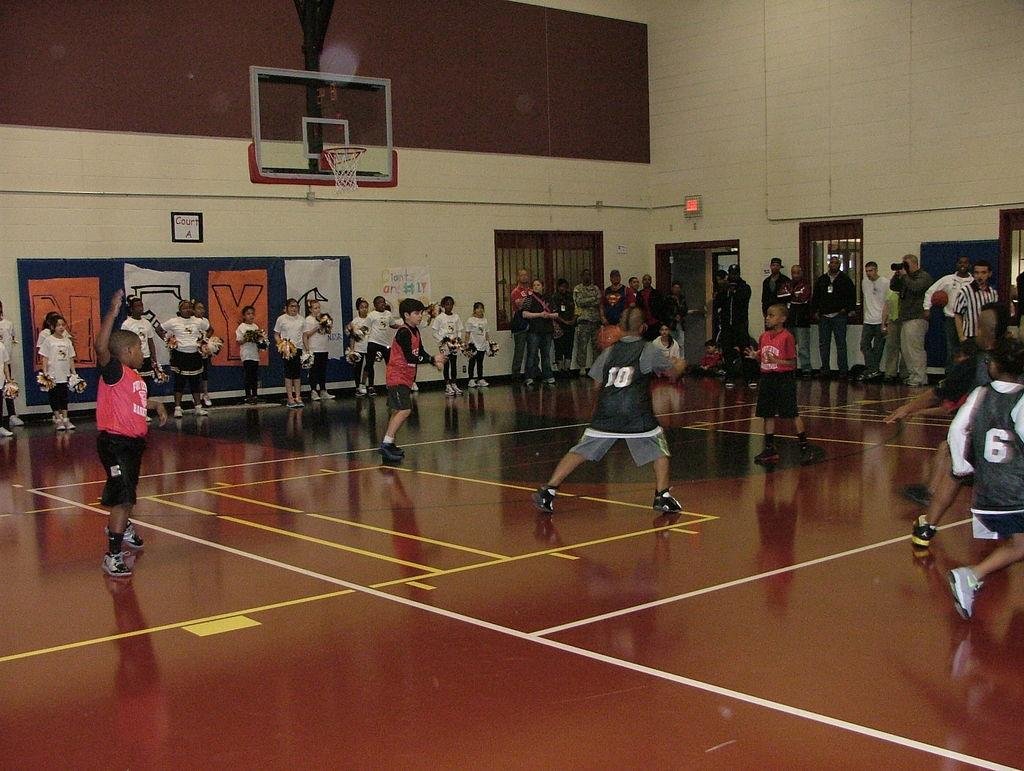<image>
Create a compact narrative representing the image presented. Inside a gymnasium, a group of boys play basketball with a sign on the wall saying "Giants are #1." 